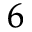<formula> <loc_0><loc_0><loc_500><loc_500>_ { 6 }</formula> 